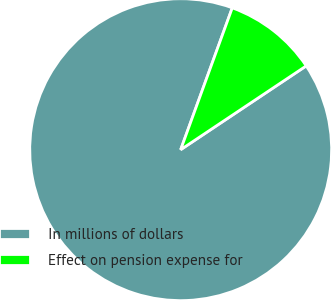<chart> <loc_0><loc_0><loc_500><loc_500><pie_chart><fcel>In millions of dollars<fcel>Effect on pension expense for<nl><fcel>89.92%<fcel>10.08%<nl></chart> 